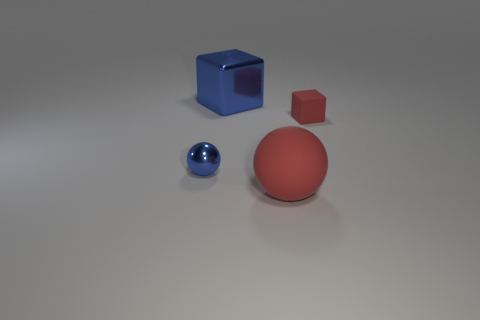Are the small thing that is in front of the matte cube and the red sphere made of the same material?
Provide a short and direct response. No. There is a ball that is right of the large block; how big is it?
Ensure brevity in your answer.  Large. There is a ball on the right side of the blue block; are there any tiny cubes right of it?
Ensure brevity in your answer.  Yes. Do the object in front of the shiny sphere and the small object that is right of the tiny blue metallic object have the same color?
Keep it short and to the point. Yes. What color is the matte block?
Your answer should be very brief. Red. There is a object that is in front of the small red matte cube and on the right side of the blue ball; what color is it?
Keep it short and to the point. Red. There is a blue object that is behind the matte block; does it have the same size as the red matte ball?
Provide a short and direct response. Yes. Are there more small metallic things in front of the blue metal cube than cyan metal things?
Offer a terse response. Yes. Do the tiny blue metal object and the large shiny thing have the same shape?
Your response must be concise. No. What is the size of the red rubber block?
Give a very brief answer. Small. 